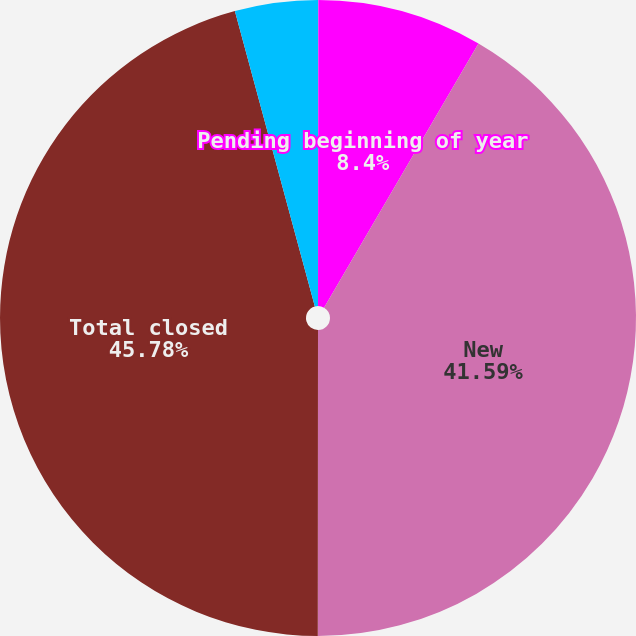Convert chart to OTSL. <chart><loc_0><loc_0><loc_500><loc_500><pie_chart><fcel>Number of claims<fcel>Pending beginning of year<fcel>New<fcel>Total closed<fcel>Pending end of year<nl><fcel>0.02%<fcel>8.4%<fcel>41.59%<fcel>45.78%<fcel>4.21%<nl></chart> 